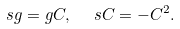Convert formula to latex. <formula><loc_0><loc_0><loc_500><loc_500>s g = g C , \ \ s C = - C ^ { 2 } .</formula> 